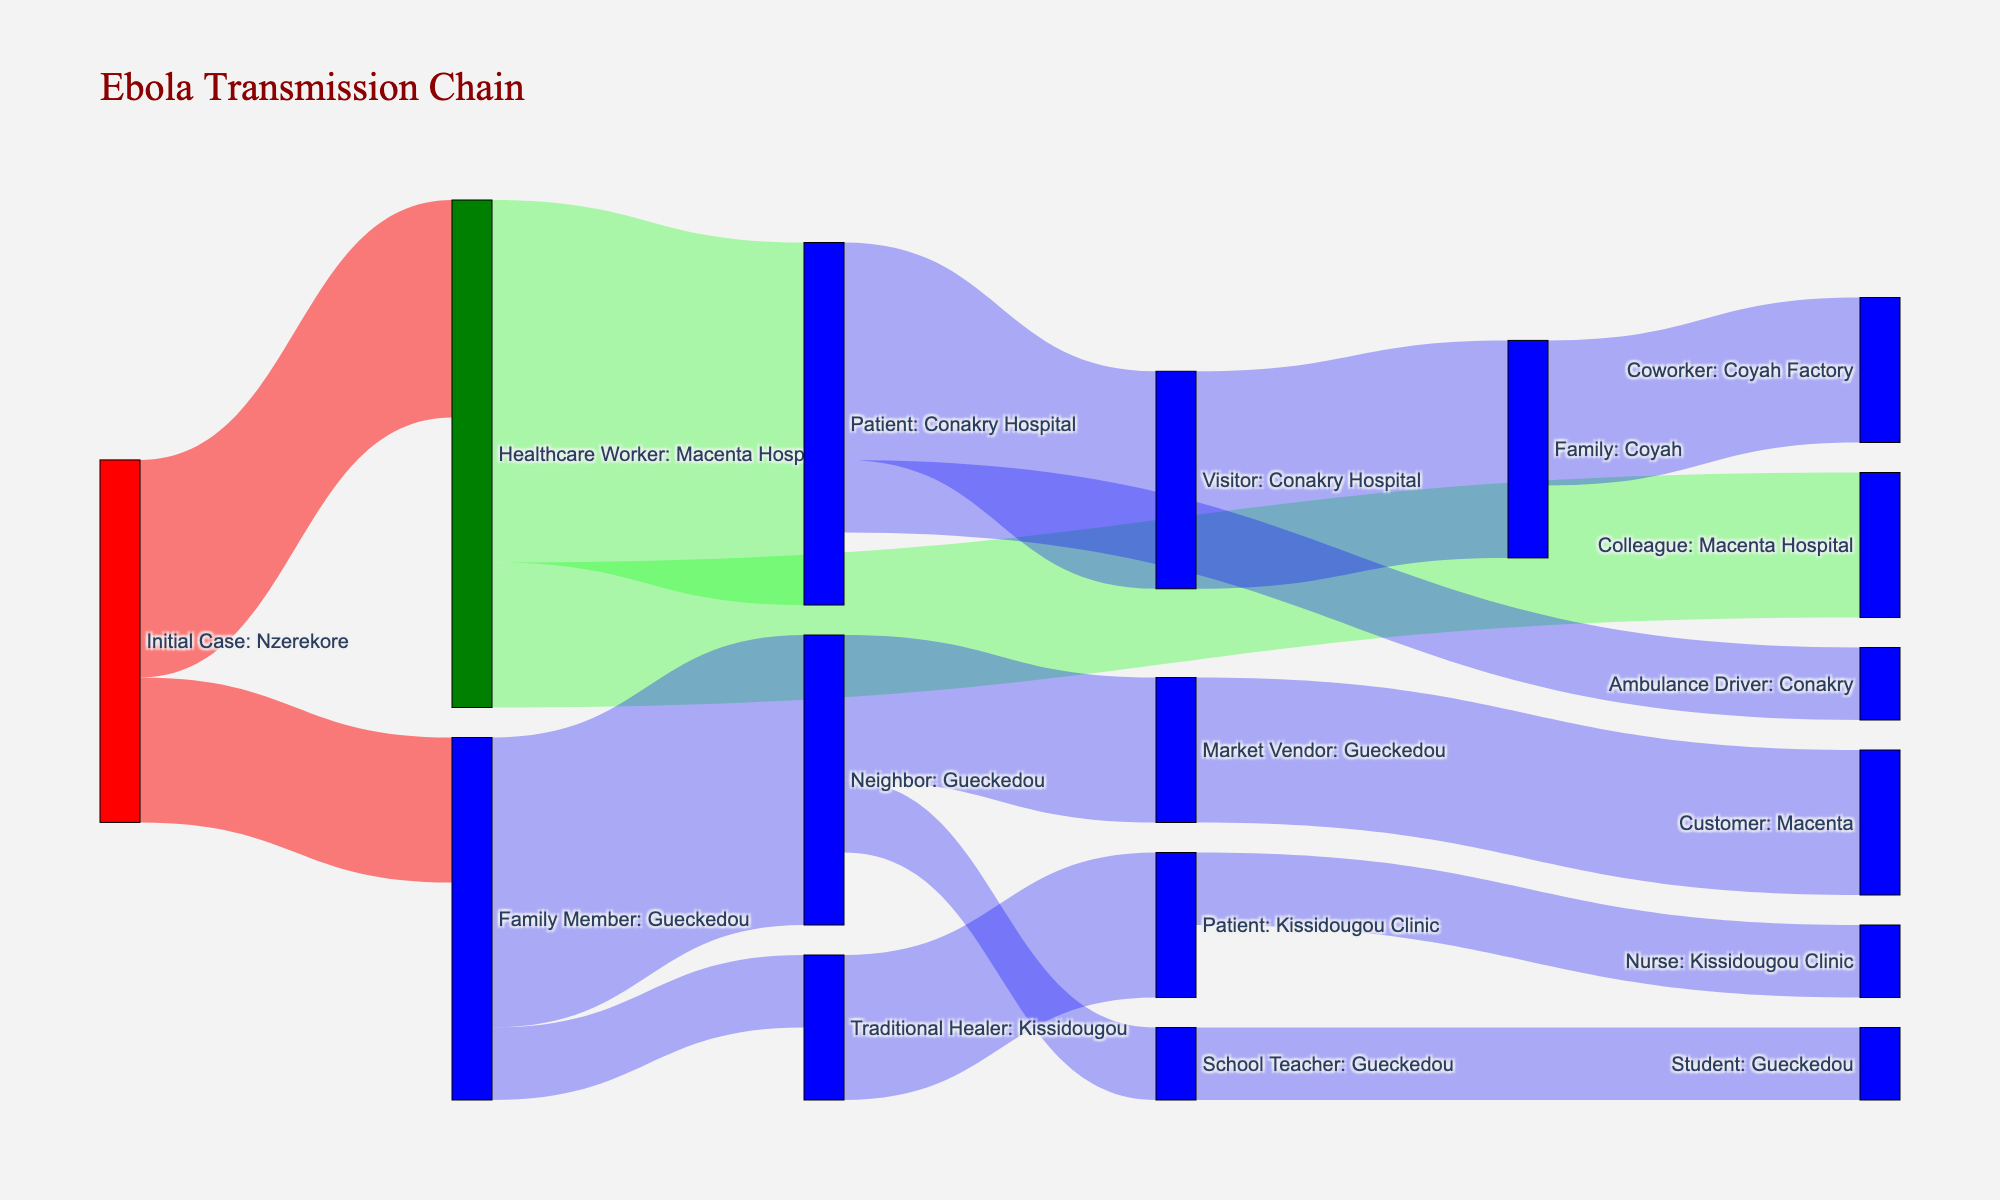Which location is the initial case linked to? The initial case is labeled as "Initial Case: Nzerekore," indicating it started in Nzerekore.
Answer: Nzerekore How many cases were linked to healthcare workers at the Macenta Hospital? By looking at the connections originating from "Healthcare Worker: Macenta Hospital," we see links with values of 5 (to Patients: Conakry Hospital) and 2 (to Colleagues: Macenta Hospital). Summing these values gives 5+2=7 cases.
Answer: 7 Which type of source leads to the most subsequent infections? "Patient: Conakry Hospital" has a subsequent infection count of 3 (Visitor: Conakry Hospital) and 1 (Ambulance Driver: Conakry), leading to 4 infections, the highest on the chart.
Answer: Patient: Conakry Hospital Calculate the total number of infections linked to "Family Member: Gueckedou". The total comes from its links to Neighbor: Gueckedou (4) and Traditional Healer: Kissidougou (1), adding up to 4+1=5.
Answer: 5 Which node has the fewest subsequent infections, and how many are there? The node "Student: Gueckedou" has only 1 subsequent infection.
Answer: Student: Gueckedou, 1 Identify the node with the highest number of incoming cases. "Patient: Conakry Hospital" has incoming connections from "Healthcare Worker: Macenta Hospital," totaling 5 cases.
Answer: Patient: Conakry Hospital Compare the infections from "Healthcare Worker: Macenta Hospital" and "Family Member: Gueckedou". Which has higher cases, and by how much? "Healthcare Worker: Macenta Hospital" has 5+2=7 cases, while "Family Member: Gueckedou" has 4+1=5. Therefore, Healthcare Worker has more cases by 7-5=2 cases.
Answer: Healthcare Worker: Macenta Hospital by 2 cases What's the total number of infections that originated from Patient nodes (both "Patient: Conakry Hospital" and "Patient: Kissidougou Clinic")? Summing the value from "Patient: Conakry Hospital" (3+1) and "Patient: Kissidougou Clinic" (1), the total is 3+1+1=5.
Answer: 5 Out of those cases linked to "Family: Coyah," how many directly lead to infections in workplaces? "Family: Coyah" leads to "Coworker: Coyah Factory" with 2 infections in the workplace.
Answer: 2 What is the color representation trend in the Sankey diagram? The diagram uses red for initial cases, green for healthcare workers, and blue for others. This coloring helps differentiate the types of nodes visually.
Answer: Red for initial cases, green for healthcare workers, blue for others 